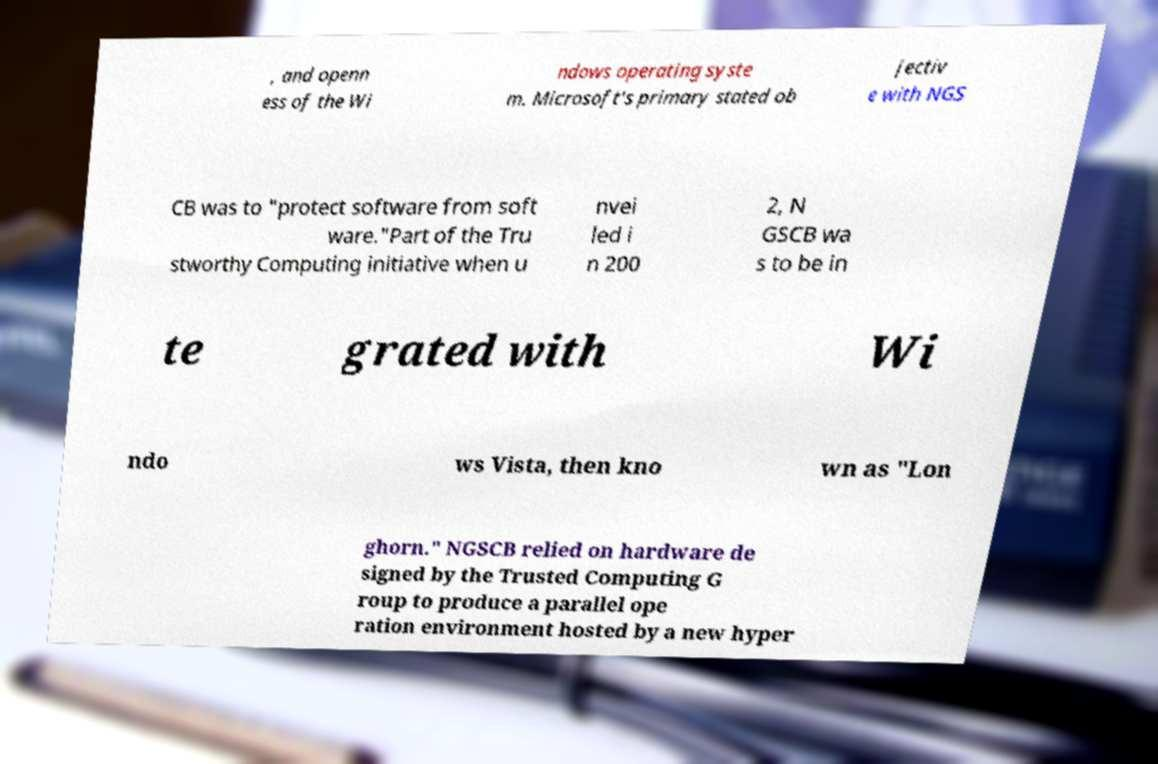There's text embedded in this image that I need extracted. Can you transcribe it verbatim? , and openn ess of the Wi ndows operating syste m. Microsoft's primary stated ob jectiv e with NGS CB was to "protect software from soft ware."Part of the Tru stworthy Computing initiative when u nvei led i n 200 2, N GSCB wa s to be in te grated with Wi ndo ws Vista, then kno wn as "Lon ghorn." NGSCB relied on hardware de signed by the Trusted Computing G roup to produce a parallel ope ration environment hosted by a new hyper 